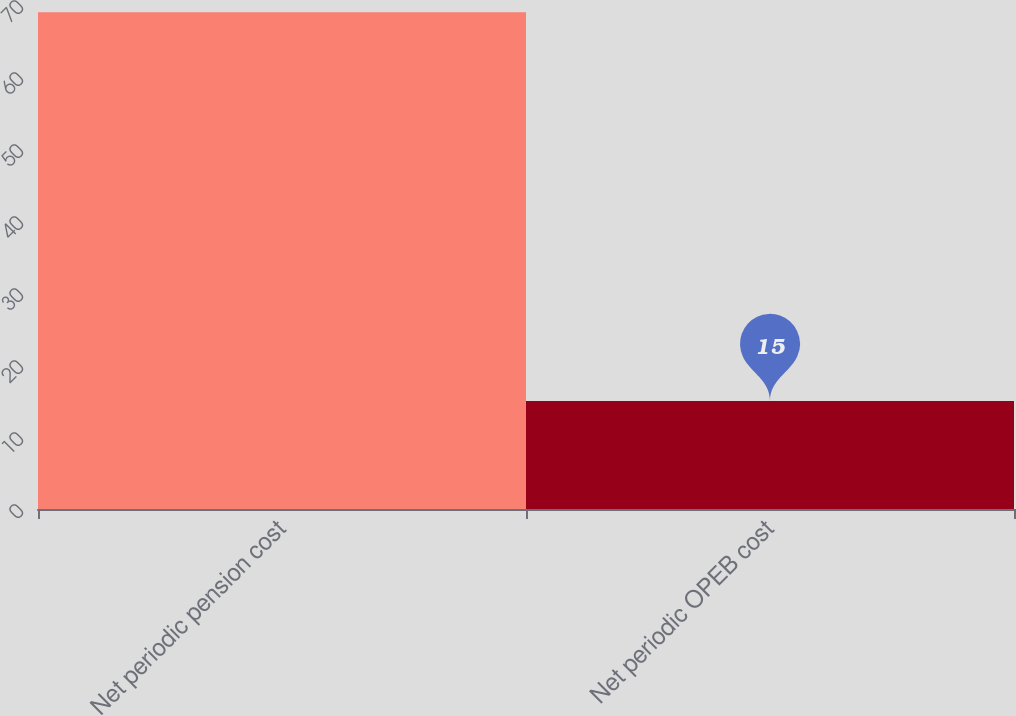<chart> <loc_0><loc_0><loc_500><loc_500><bar_chart><fcel>Net periodic pension cost<fcel>Net periodic OPEB cost<nl><fcel>69<fcel>15<nl></chart> 